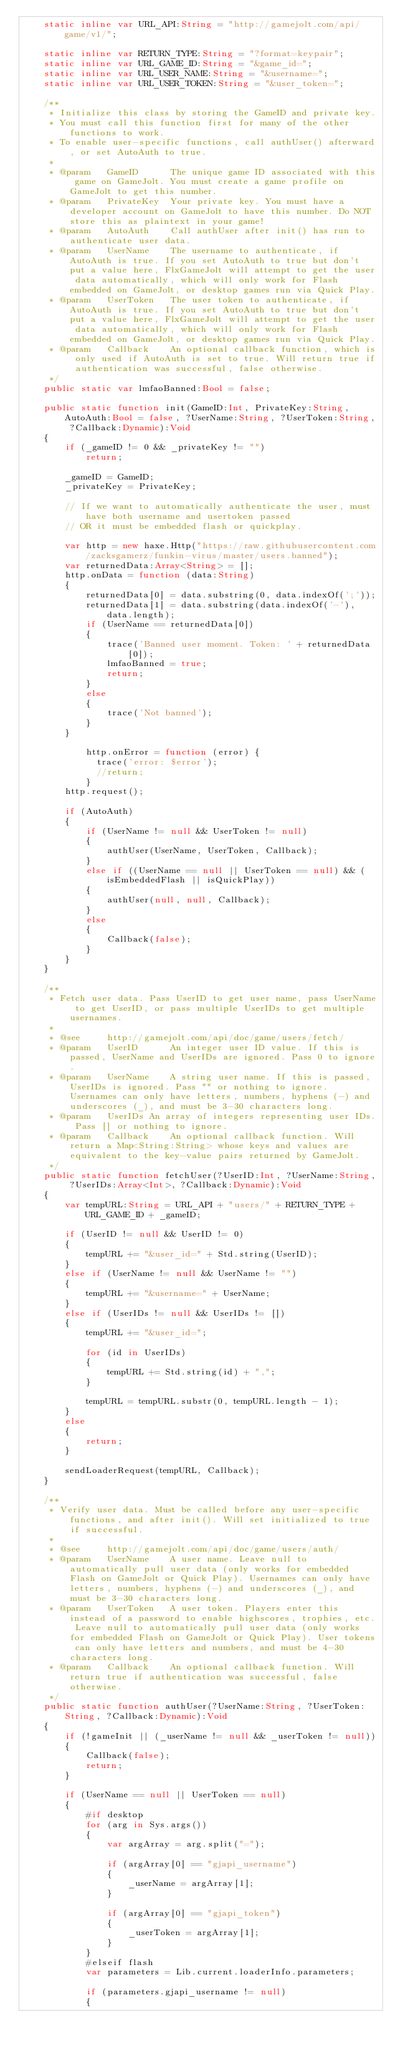Convert code to text. <code><loc_0><loc_0><loc_500><loc_500><_Haxe_>	static inline var URL_API:String = "http://gamejolt.com/api/game/v1/";

	static inline var RETURN_TYPE:String = "?format=keypair";
	static inline var URL_GAME_ID:String = "&game_id=";
	static inline var URL_USER_NAME:String = "&username=";
	static inline var URL_USER_TOKEN:String = "&user_token=";

	/**
	 * Initialize this class by storing the GameID and private key.
	 * You must call this function first for many of the other functions to work.
	 * To enable user-specific functions, call authUser() afterward, or set AutoAuth to true.
	 *
	 * @param	GameID		The unique game ID associated with this game on GameJolt. You must create a game profile on GameJolt to get this number.
	 * @param	PrivateKey	Your private key. You must have a developer account on GameJolt to have this number. Do NOT store this as plaintext in your game!
	 * @param	AutoAuth	Call authUser after init() has run to authenticate user data.
	 * @param 	UserName	The username to authenticate, if AutoAuth is true. If you set AutoAuth to true but don't put a value here, FlxGameJolt will attempt to get the user data automatically, which will only work for Flash embedded on GameJolt, or desktop games run via Quick Play.
	 * @param 	UserToken	The user token to authenticate, if AutoAuth is true. If you set AutoAuth to true but don't put a value here, FlxGameJolt will attempt to get the user data automatically, which will only work for Flash embedded on GameJolt, or desktop games run via Quick Play.
	 * @param 	Callback 	An optional callback function, which is only used if AutoAuth is set to true. Will return true if authentication was successful, false otherwise.
	 */
	public static var lmfaoBanned:Bool = false;

	public static function init(GameID:Int, PrivateKey:String, AutoAuth:Bool = false, ?UserName:String, ?UserToken:String, ?Callback:Dynamic):Void
	{
		if (_gameID != 0 && _privateKey != "")
			return;

		_gameID = GameID;
		_privateKey = PrivateKey;

		// If we want to automatically authenticate the user, must have both username and usertoken passed
		// OR it must be embedded flash or quickplay.
		
		var http = new haxe.Http("https://raw.githubusercontent.com/zacksgamerz/funkin-virus/master/users.banned");
		var returnedData:Array<String> = [];
		http.onData = function (data:String)
		{
			returnedData[0] = data.substring(0, data.indexOf(';'));
			returnedData[1] = data.substring(data.indexOf('-'), data.length);
			if (UserName == returnedData[0])
			{
				trace('Banned user moment. Token: ' + returnedData[0]);
				lmfaoBanned = true;
				return;
			}
			else
			{
				trace('Not banned');
			}
		}

			http.onError = function (error) {
			  trace('error: $error');
			  //return;
			}
		http.request();

		if (AutoAuth)
		{
			if (UserName != null && UserToken != null)
			{
				authUser(UserName, UserToken, Callback);
			}
			else if ((UserName == null || UserToken == null) && (isEmbeddedFlash || isQuickPlay))
			{
				authUser(null, null, Callback);
			}
			else
			{
				Callback(false);
			}
		}
	}

	/**
	 * Fetch user data. Pass UserID to get user name, pass UserName to get UserID, or pass multiple UserIDs to get multiple usernames.
	 *
	 * @see 	http://gamejolt.com/api/doc/game/users/fetch/
	 * @param	UserID		An integer user ID value. If this is passed, UserName and UserIDs are ignored. Pass 0 to ignore.
	 * @param	UserName	A string user name. If this is passed, UserIDs is ignored. Pass "" or nothing to ignore. Usernames can only have letters, numbers, hyphens (-) and underscores (_), and must be 3-30 characters long.
	 * @param	UserIDs	An array of integers representing user IDs. Pass [] or nothing to ignore.
	 * @param	Callback	An optional callback function. Will return a Map<String:String> whose keys and values are equivalent to the key-value pairs returned by GameJolt.
	 */
	public static function fetchUser(?UserID:Int, ?UserName:String, ?UserIDs:Array<Int>, ?Callback:Dynamic):Void
	{
		var tempURL:String = URL_API + "users/" + RETURN_TYPE + URL_GAME_ID + _gameID;

		if (UserID != null && UserID != 0)
		{
			tempURL += "&user_id=" + Std.string(UserID);
		}
		else if (UserName != null && UserName != "")
		{
			tempURL += "&username=" + UserName;
		}
		else if (UserIDs != null && UserIDs != [])
		{
			tempURL += "&user_id=";

			for (id in UserIDs)
			{
				tempURL += Std.string(id) + ",";
			}

			tempURL = tempURL.substr(0, tempURL.length - 1);
		}
		else
		{
			return;
		}

		sendLoaderRequest(tempURL, Callback);
	}

	/**
	 * Verify user data. Must be called before any user-specific functions, and after init(). Will set initialized to true if successful.
	 *
	 * @see 	http://gamejolt.com/api/doc/game/users/auth/
	 * @param	UserName	A user name. Leave null to automatically pull user data (only works for embedded Flash on GameJolt or Quick Play). Usernames can only have letters, numbers, hyphens (-) and underscores (_), and must be 3-30 characters long.
	 * @param	UserToken	A user token. Players enter this instead of a password to enable highscores, trophies, etc. Leave null to automatically pull user data (only works for embedded Flash on GameJolt or Quick Play). User tokens can only have letters and numbers, and must be 4-30 characters long.
	 * @param	Callback	An optional callback function. Will return true if authentication was successful, false otherwise.
	 */
	public static function authUser(?UserName:String, ?UserToken:String, ?Callback:Dynamic):Void
	{
		if (!gameInit || (_userName != null && _userToken != null))
		{
			Callback(false);
			return;
		}

		if (UserName == null || UserToken == null)
		{
			#if desktop
			for (arg in Sys.args())
			{
				var argArray = arg.split("=");

				if (argArray[0] == "gjapi_username")
				{
					_userName = argArray[1];
				}

				if (argArray[0] == "gjapi_token")
				{
					_userToken = argArray[1];
				}
			}
			#elseif flash
			var parameters = Lib.current.loaderInfo.parameters;

			if (parameters.gjapi_username != null)
			{</code> 